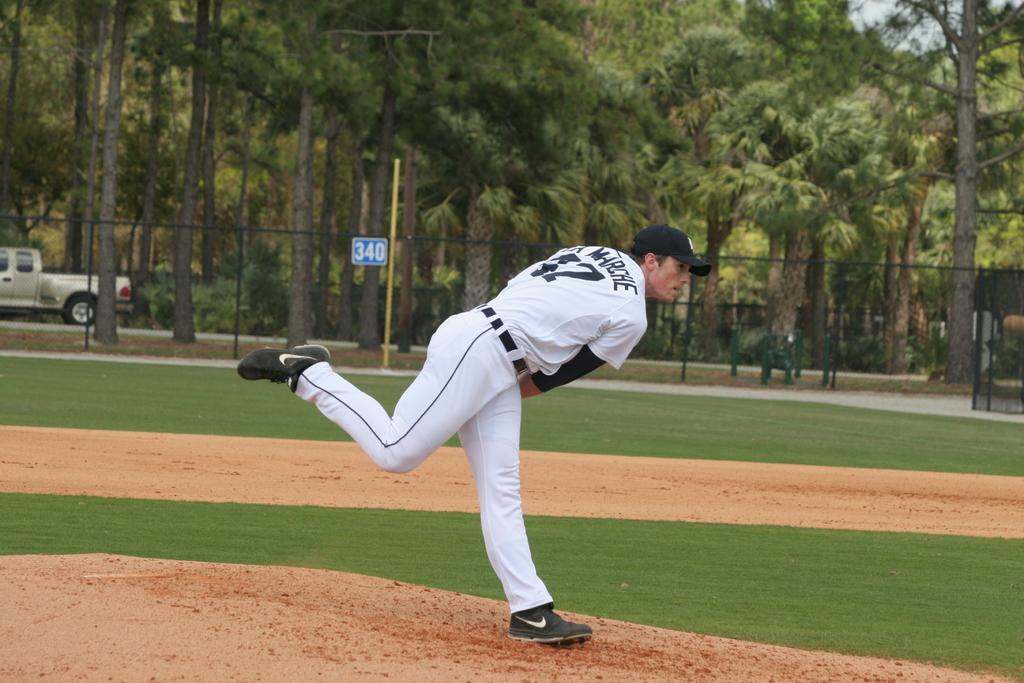<image>
Provide a brief description of the given image. a pitcher throwing a ball and with the number 2 on his jersey 